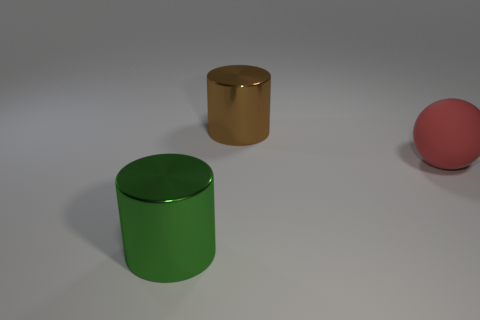Is there anything else that is made of the same material as the red ball?
Your response must be concise. No. What number of green objects are there?
Make the answer very short. 1. The cylinder in front of the shiny thing to the right of the large shiny object that is in front of the big brown metallic cylinder is what color?
Offer a terse response. Green. Are there fewer big gray shiny spheres than large red objects?
Provide a succinct answer. Yes. There is another metal object that is the same shape as the big brown object; what color is it?
Provide a short and direct response. Green. There is a large cylinder that is made of the same material as the big green object; what is its color?
Your response must be concise. Brown. What number of other brown objects are the same size as the brown metal thing?
Offer a terse response. 0. What material is the large red object?
Your answer should be compact. Rubber. Are there more metal cylinders than big brown objects?
Provide a succinct answer. Yes. Do the big green shiny object and the brown thing have the same shape?
Provide a succinct answer. Yes. 